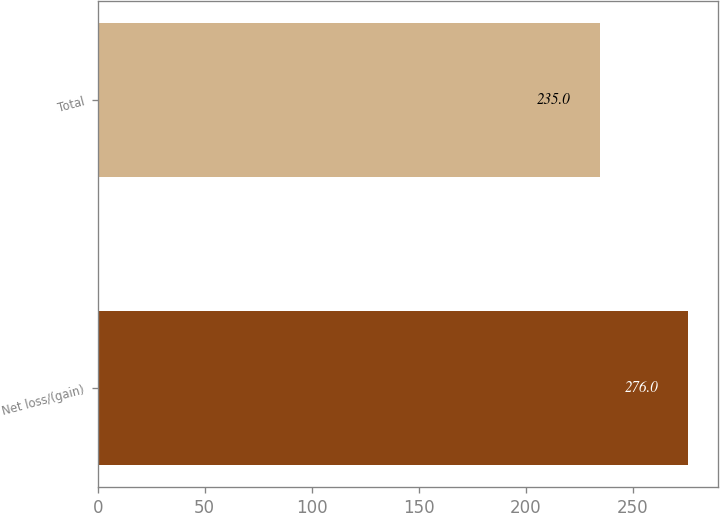Convert chart to OTSL. <chart><loc_0><loc_0><loc_500><loc_500><bar_chart><fcel>Net loss/(gain)<fcel>Total<nl><fcel>276<fcel>235<nl></chart> 